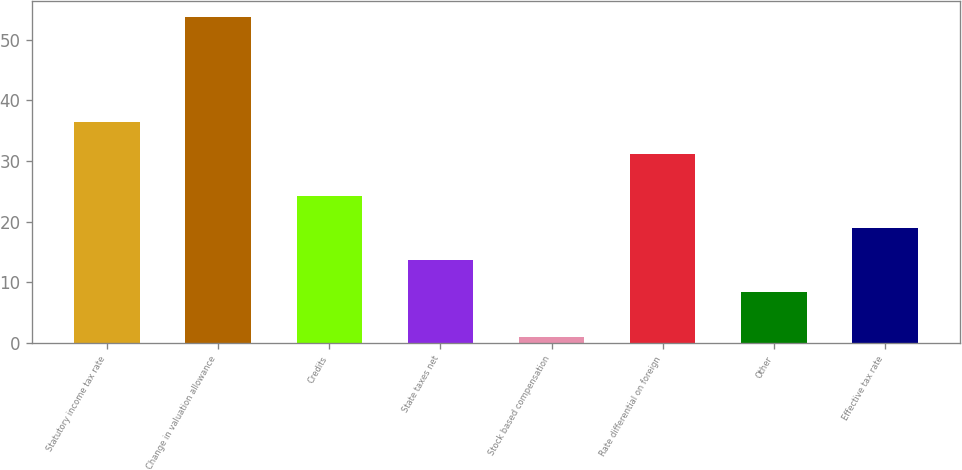Convert chart. <chart><loc_0><loc_0><loc_500><loc_500><bar_chart><fcel>Statutory income tax rate<fcel>Change in valuation allowance<fcel>Credits<fcel>State taxes net<fcel>Stock based compensation<fcel>Rate differential on foreign<fcel>Other<fcel>Effective tax rate<nl><fcel>36.38<fcel>53.7<fcel>24.24<fcel>13.68<fcel>0.9<fcel>31.1<fcel>8.4<fcel>18.96<nl></chart> 